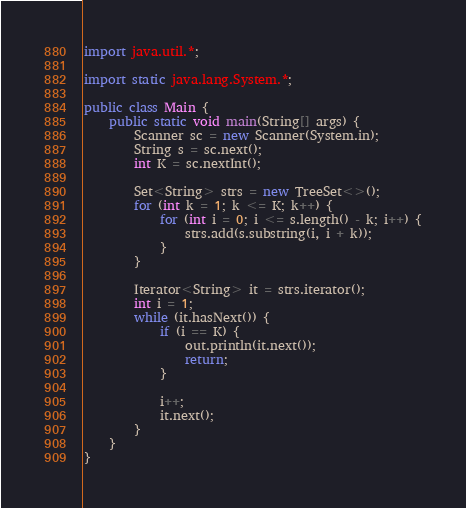<code> <loc_0><loc_0><loc_500><loc_500><_Java_>import java.util.*;

import static java.lang.System.*;

public class Main {
    public static void main(String[] args) {
        Scanner sc = new Scanner(System.in);
        String s = sc.next();
        int K = sc.nextInt();

        Set<String> strs = new TreeSet<>();
        for (int k = 1; k <= K; k++) {
            for (int i = 0; i <= s.length() - k; i++) {
                strs.add(s.substring(i, i + k));
            }
        }

        Iterator<String> it = strs.iterator();
        int i = 1;
        while (it.hasNext()) {
            if (i == K) {
                out.println(it.next());
                return;
            }

            i++;
            it.next();
        }
    }
}</code> 